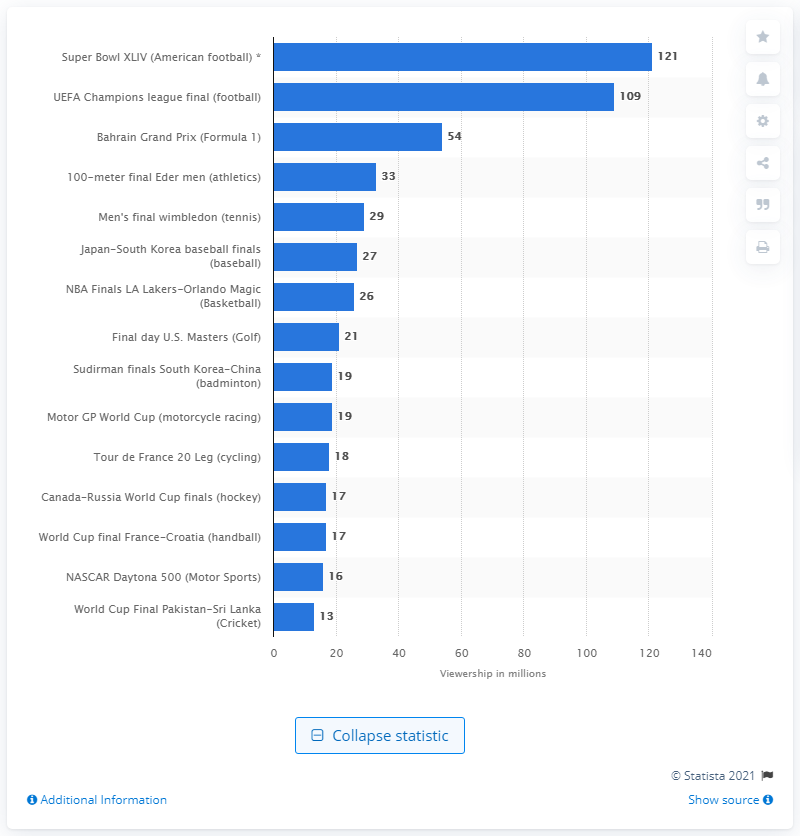Give some essential details in this illustration. A large number of people watched the Handball World Cup Final, which was estimated to have been viewed by 17... 